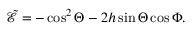Convert formula to latex. <formula><loc_0><loc_0><loc_500><loc_500>\tilde { \mathcal { E } } = - \cos ^ { 2 } \Theta - 2 h \sin \Theta \cos \Phi .</formula> 